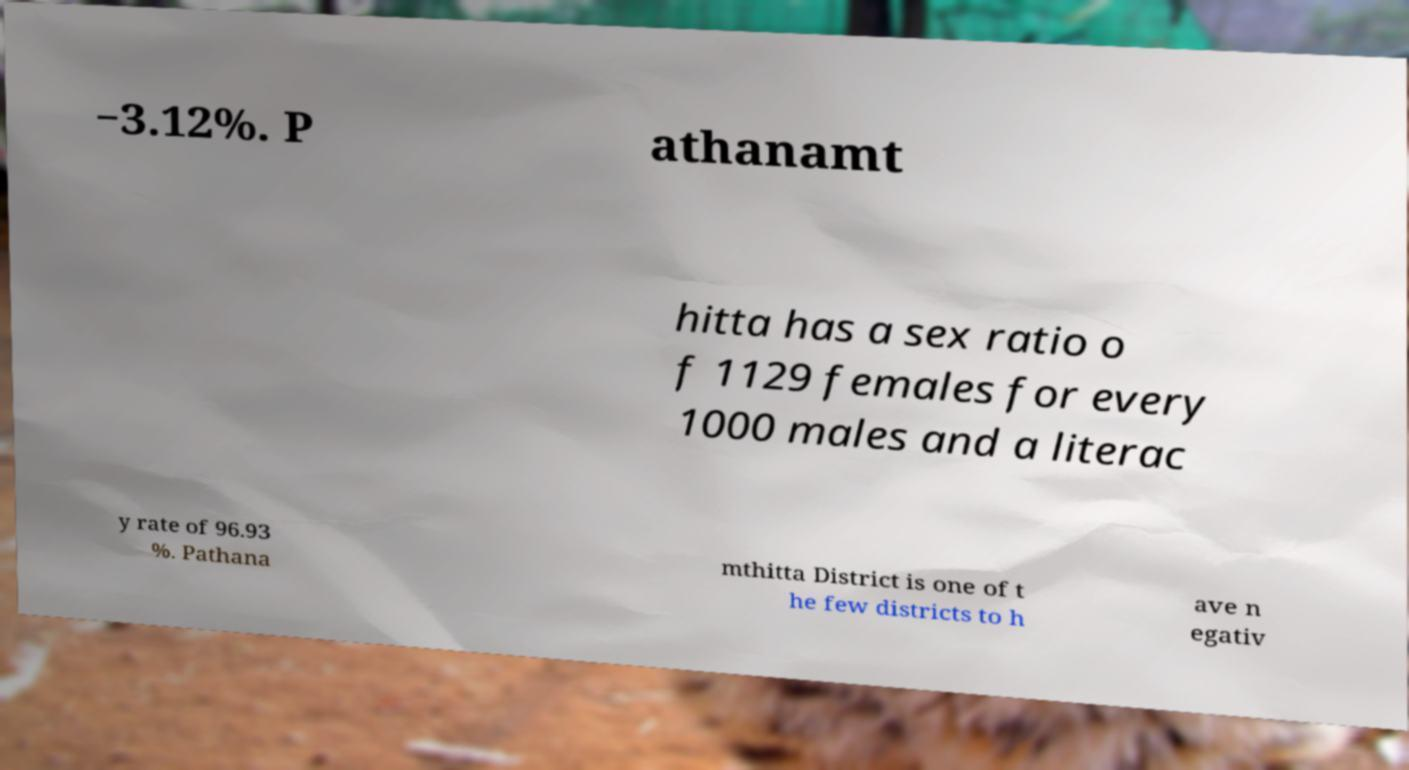Can you read and provide the text displayed in the image?This photo seems to have some interesting text. Can you extract and type it out for me? −3.12%. P athanamt hitta has a sex ratio o f 1129 females for every 1000 males and a literac y rate of 96.93 %. Pathana mthitta District is one of t he few districts to h ave n egativ 